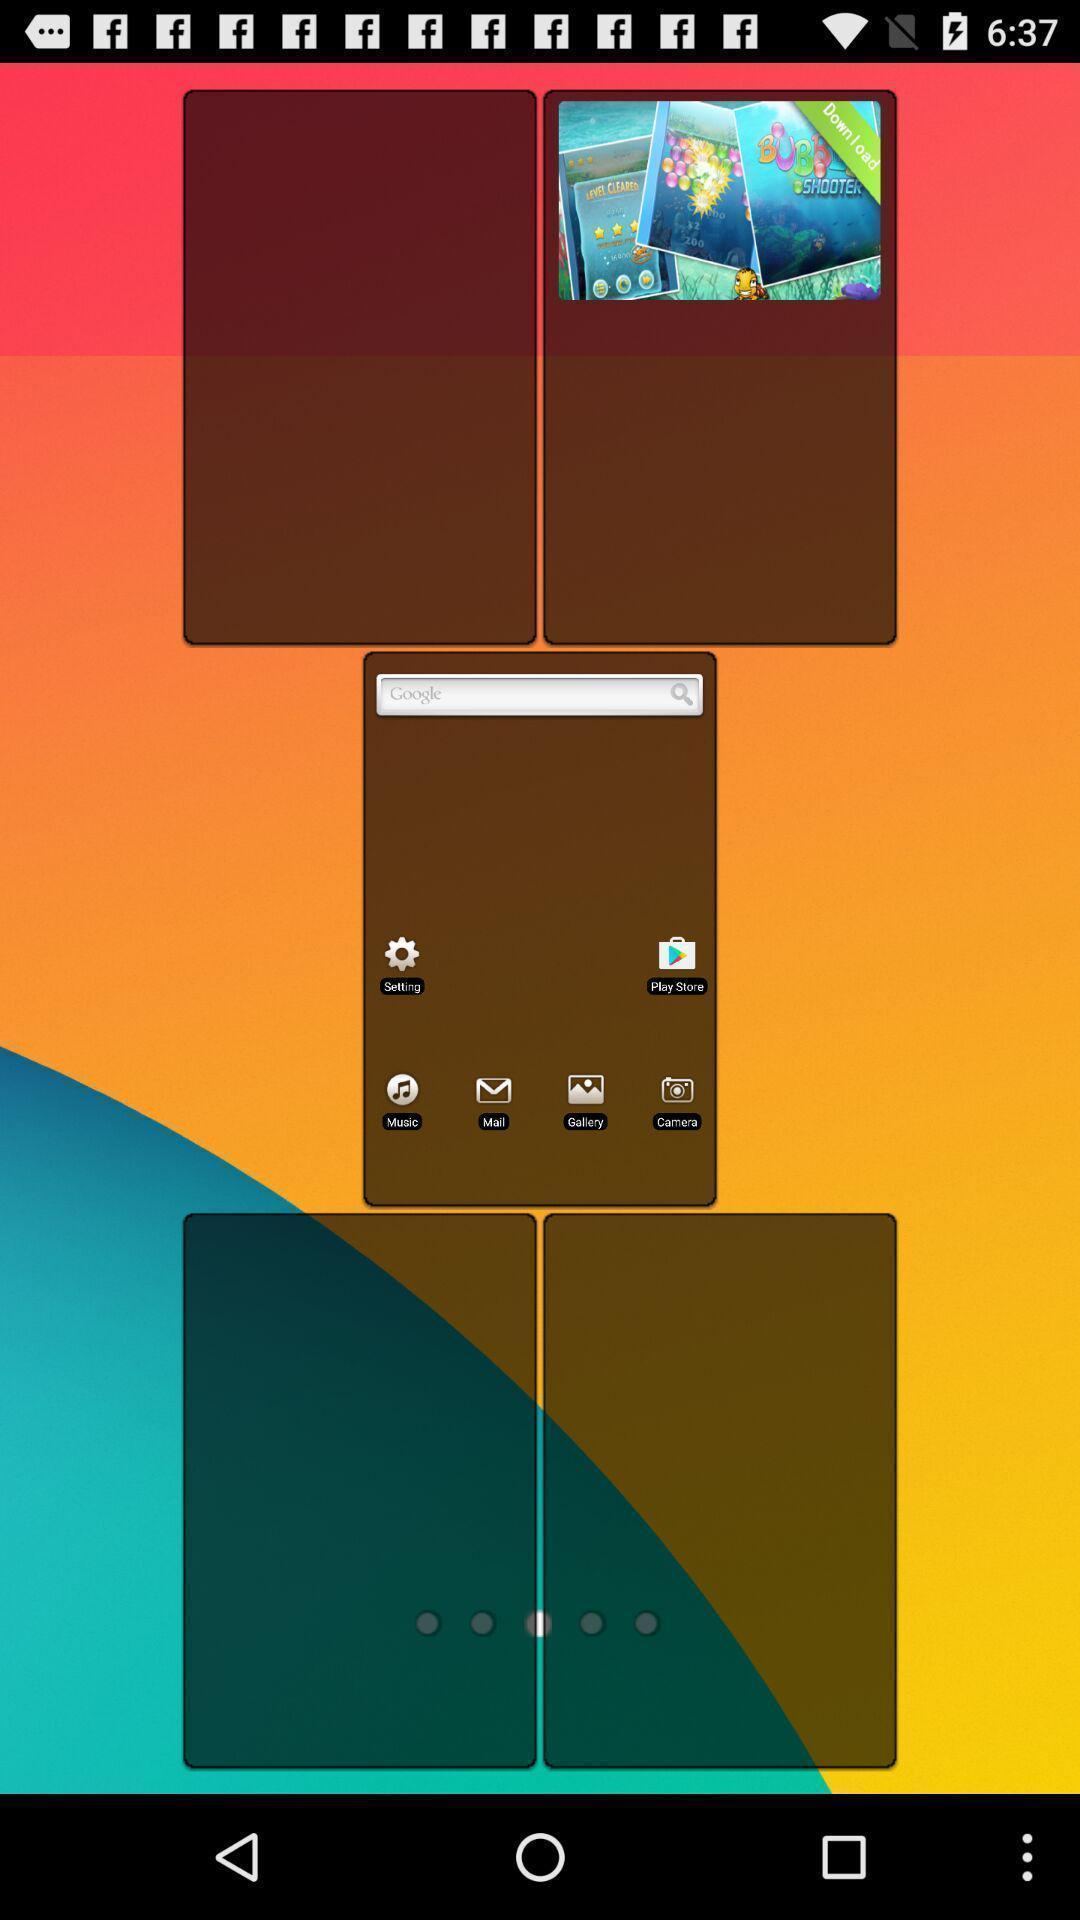Tell me about the visual elements in this screen capture. Screen displaying the multiple widgets. 